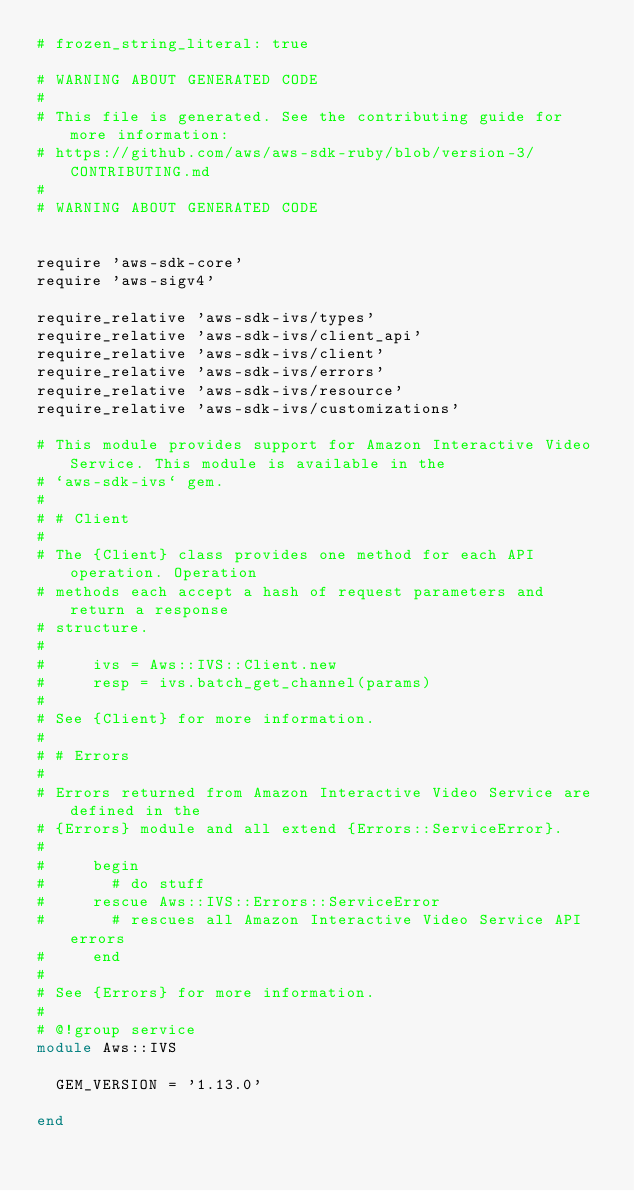Convert code to text. <code><loc_0><loc_0><loc_500><loc_500><_Ruby_># frozen_string_literal: true

# WARNING ABOUT GENERATED CODE
#
# This file is generated. See the contributing guide for more information:
# https://github.com/aws/aws-sdk-ruby/blob/version-3/CONTRIBUTING.md
#
# WARNING ABOUT GENERATED CODE


require 'aws-sdk-core'
require 'aws-sigv4'

require_relative 'aws-sdk-ivs/types'
require_relative 'aws-sdk-ivs/client_api'
require_relative 'aws-sdk-ivs/client'
require_relative 'aws-sdk-ivs/errors'
require_relative 'aws-sdk-ivs/resource'
require_relative 'aws-sdk-ivs/customizations'

# This module provides support for Amazon Interactive Video Service. This module is available in the
# `aws-sdk-ivs` gem.
#
# # Client
#
# The {Client} class provides one method for each API operation. Operation
# methods each accept a hash of request parameters and return a response
# structure.
#
#     ivs = Aws::IVS::Client.new
#     resp = ivs.batch_get_channel(params)
#
# See {Client} for more information.
#
# # Errors
#
# Errors returned from Amazon Interactive Video Service are defined in the
# {Errors} module and all extend {Errors::ServiceError}.
#
#     begin
#       # do stuff
#     rescue Aws::IVS::Errors::ServiceError
#       # rescues all Amazon Interactive Video Service API errors
#     end
#
# See {Errors} for more information.
#
# @!group service
module Aws::IVS

  GEM_VERSION = '1.13.0'

end
</code> 